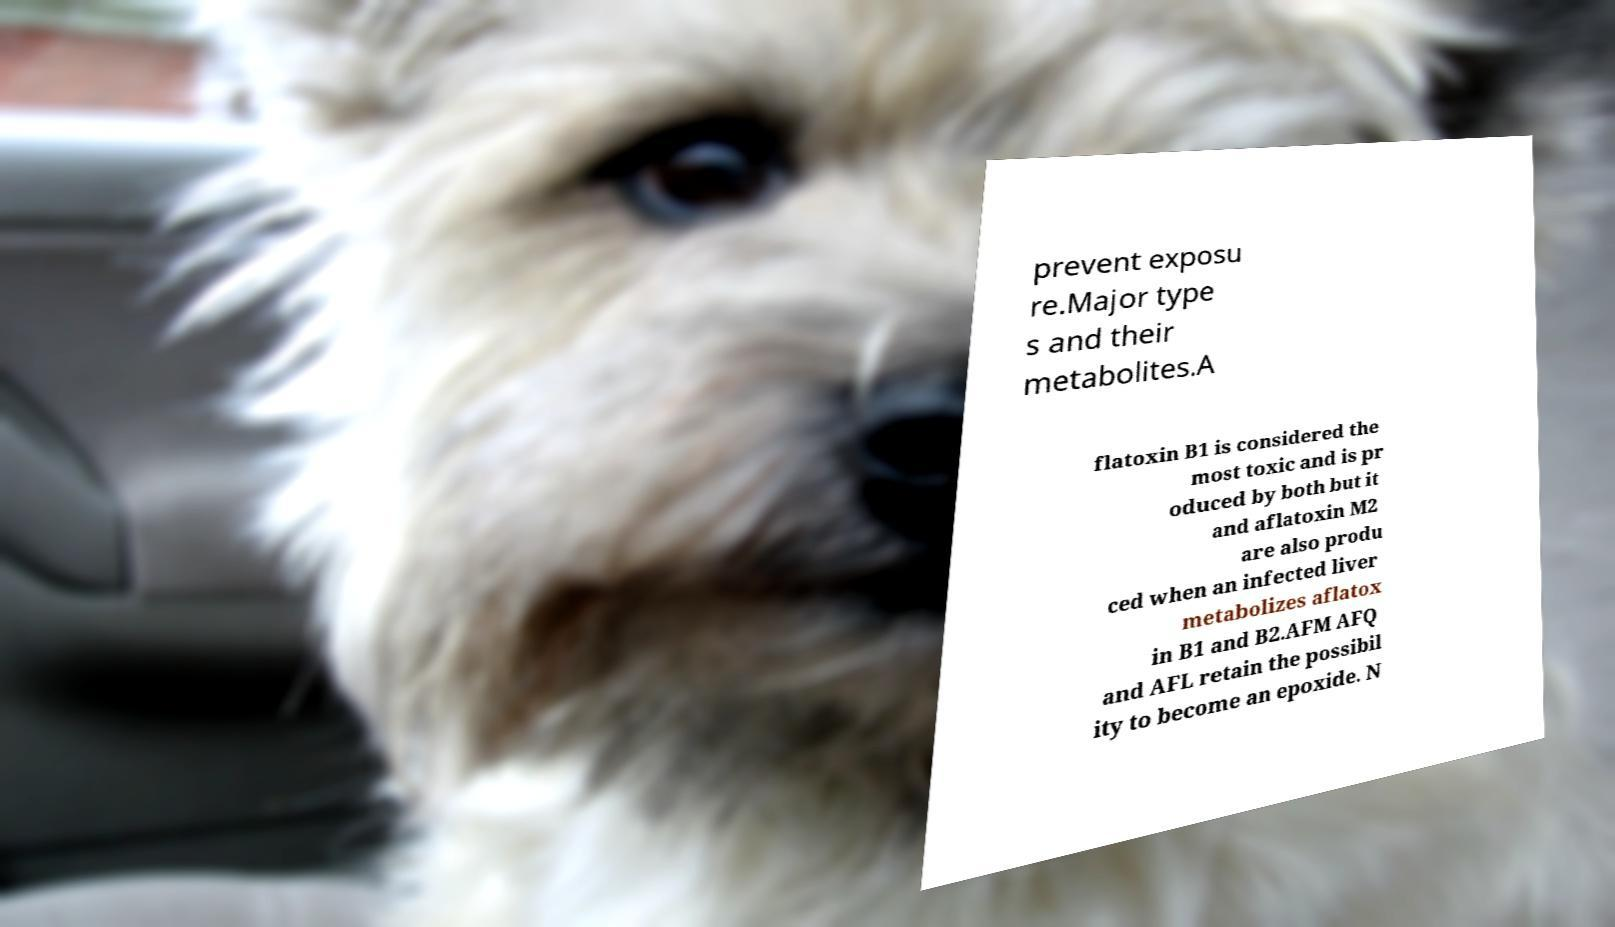What messages or text are displayed in this image? I need them in a readable, typed format. prevent exposu re.Major type s and their metabolites.A flatoxin B1 is considered the most toxic and is pr oduced by both but it and aflatoxin M2 are also produ ced when an infected liver metabolizes aflatox in B1 and B2.AFM AFQ and AFL retain the possibil ity to become an epoxide. N 